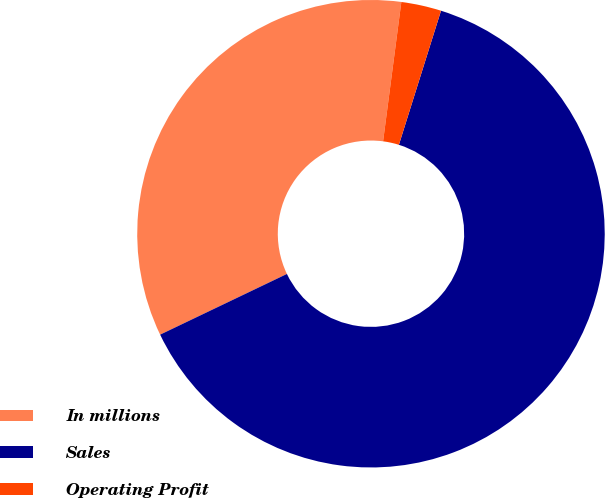Convert chart to OTSL. <chart><loc_0><loc_0><loc_500><loc_500><pie_chart><fcel>In millions<fcel>Sales<fcel>Operating Profit<nl><fcel>34.18%<fcel>63.05%<fcel>2.77%<nl></chart> 